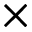<formula> <loc_0><loc_0><loc_500><loc_500>\times</formula> 